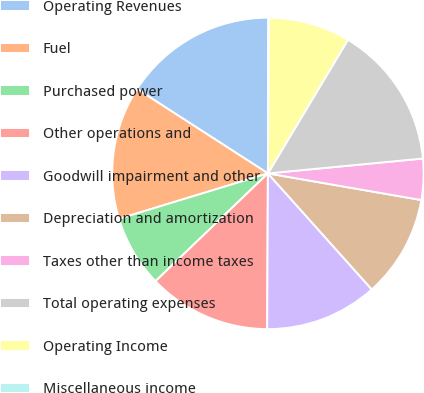<chart> <loc_0><loc_0><loc_500><loc_500><pie_chart><fcel>Operating Revenues<fcel>Fuel<fcel>Purchased power<fcel>Other operations and<fcel>Goodwill impairment and other<fcel>Depreciation and amortization<fcel>Taxes other than income taxes<fcel>Total operating expenses<fcel>Operating Income<fcel>Miscellaneous income<nl><fcel>15.95%<fcel>13.83%<fcel>7.45%<fcel>12.76%<fcel>11.7%<fcel>10.64%<fcel>4.26%<fcel>14.89%<fcel>8.51%<fcel>0.01%<nl></chart> 